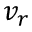<formula> <loc_0><loc_0><loc_500><loc_500>v _ { r }</formula> 